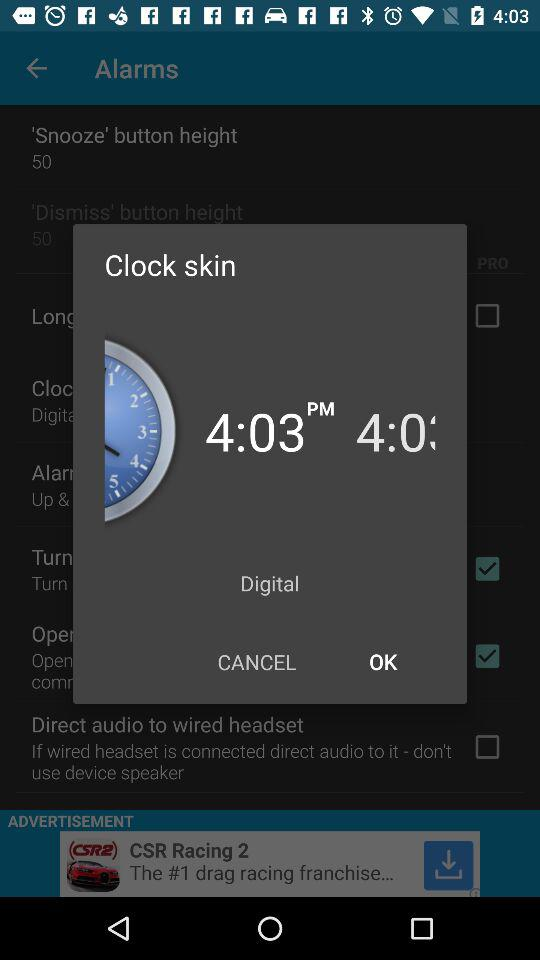What time is the clock skin showing? The clock skin is showing 4:03 PM. 